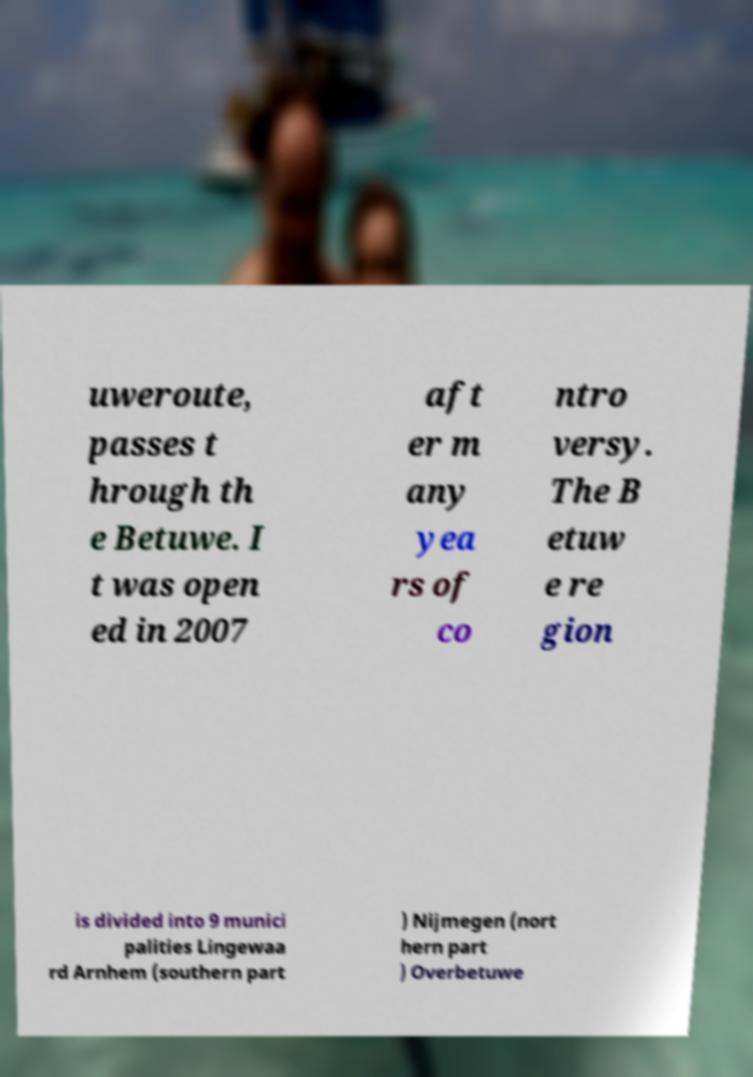Can you read and provide the text displayed in the image?This photo seems to have some interesting text. Can you extract and type it out for me? uweroute, passes t hrough th e Betuwe. I t was open ed in 2007 aft er m any yea rs of co ntro versy. The B etuw e re gion is divided into 9 munici palities Lingewaa rd Arnhem (southern part ) Nijmegen (nort hern part ) Overbetuwe 